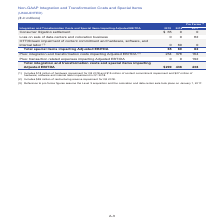According to Centurylink's financial document, What does the OTT/Stream impairment of content commitment and hardware, software, and internal labor costs in 2018 include? $18 million of hardware impairment for Q3 2018 and $15 million of content commitment impairment and $27 million of hardware, software and internal labor impairment in Q1 2018. The document states: "(1) Includes $18 million of hardware impairment for Q3 2018 and $15 million of content commitment impairment and $27 million of hardware, software and..." Also, What does the integration and transformation costs impacting Adjusted EBITDA include? $55 million of restructuring reserve impairment for Q2 2018. The document states: "(2) Includes $55 million of restructuring reserve impairment for Q2 2018...." Also, What does the reference to pro forma figures assume? the Level 3 acquisition and the colocation and data center sale took place on January 1, 2017. The document states: "(3) Reference to pro forma figures assume the Level 3 acquisition and the colocation and data center sale took place on January 1, 2017...." Also, How many cost components are included in the OTT/Stream impairment of content commitment and hardware, software, and internal labor costs in 2018? Counting the relevant items in the document: hardware impairment, content commitment impairment, hardware, software and internal labor impairment, I find 3 instances. The key data points involved are: content commitment impairment, hardware impairment, hardware, software and internal labor impairment. Also, can you calculate: What is the change in total special items impacting adjusted EBITDA between 2018 and 2019? Based on the calculation: $65-$60, the result is 5 (in millions). This is based on the information: "Total special items impacting Adjusted EBITDA 65 60 82 Total special items impacting Adjusted EBITDA 65 60 82..." The key data points involved are: 60, 65. Also, can you calculate: What is the percentage change in total special items impacting adjusted EBITDA between 2018 and 2019? To answer this question, I need to perform calculations using the financial data. The calculation is: ($65-$60)/$60, which equals 8.33 (percentage). This is based on the information: "Total special items impacting Adjusted EBITDA 65 60 82 Total special items impacting Adjusted EBITDA 65 60 82..." The key data points involved are: 60, 65. 